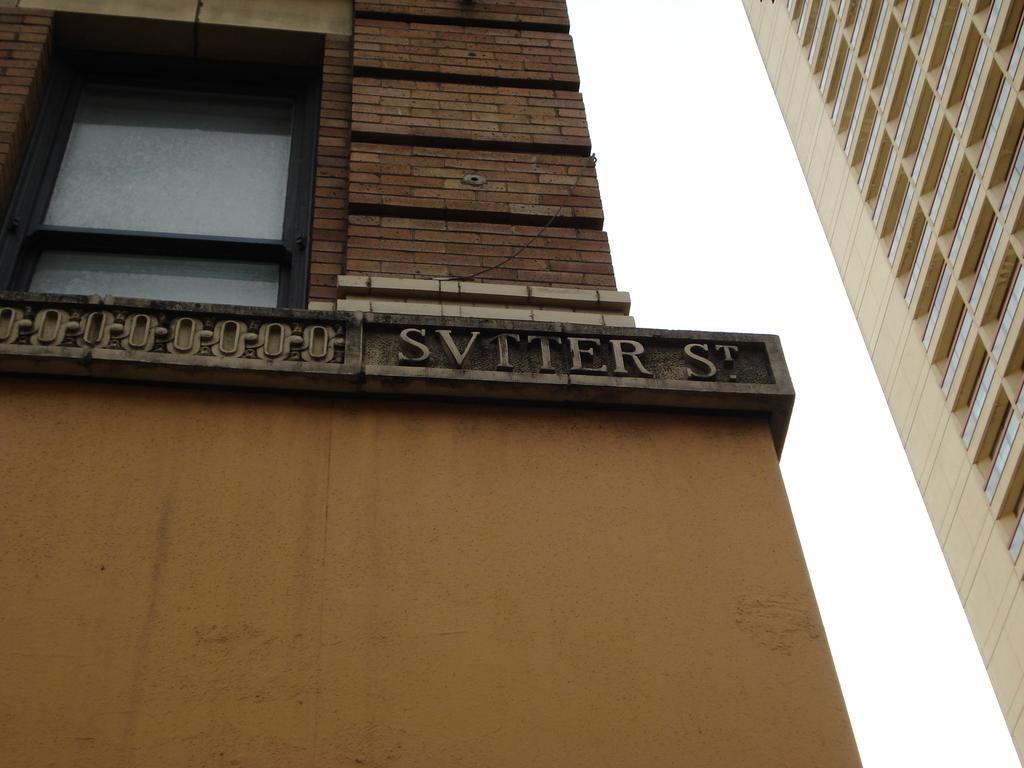How would you summarize this image in a sentence or two? In this picture we can see some text, a window, glass objects and a brick wall is visible on a building visible on the left side. We can see a building on the right side. There is the sky visible on top of the picture. 